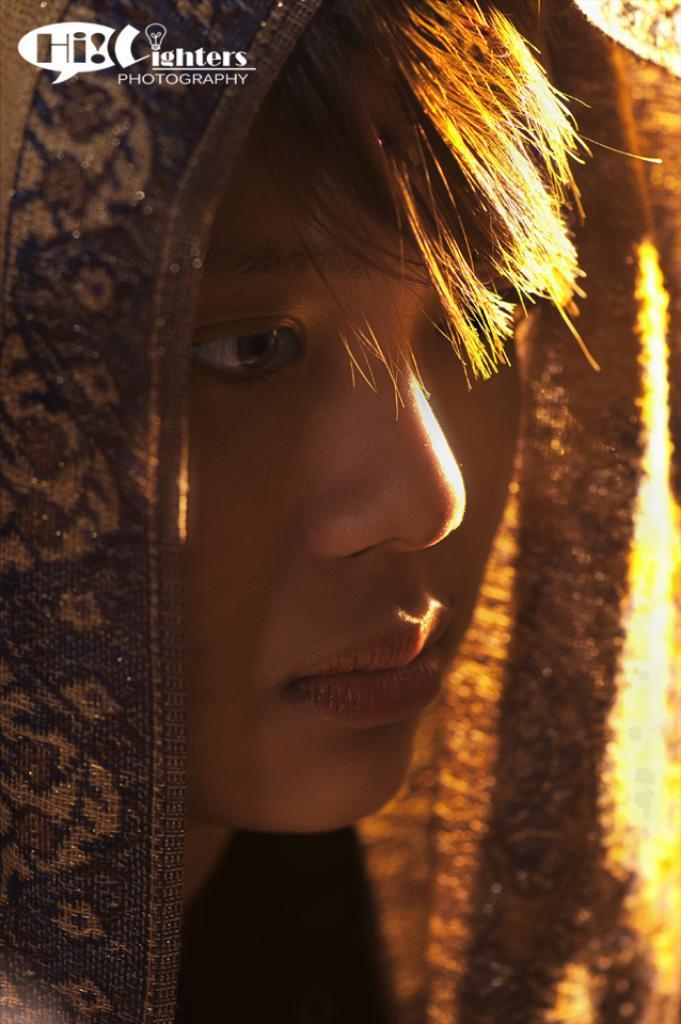Describe this image in one or two sentences. Here we can see a person and there is a cloth on the head. On the left side at the top corner we can see a text and log on the image. 